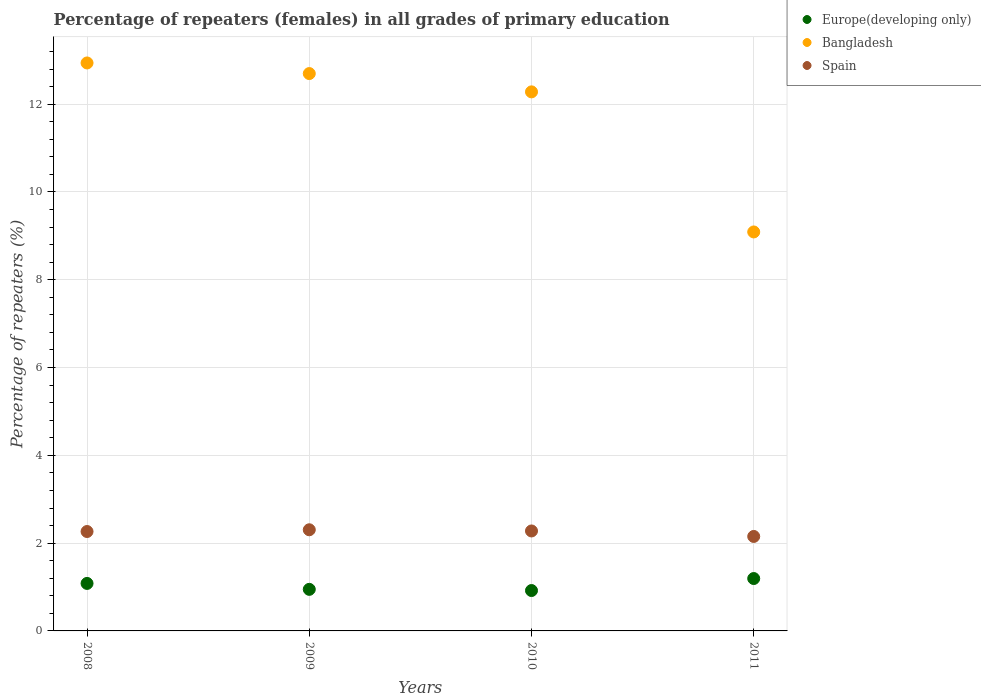What is the percentage of repeaters (females) in Spain in 2008?
Offer a terse response. 2.26. Across all years, what is the maximum percentage of repeaters (females) in Bangladesh?
Ensure brevity in your answer.  12.94. Across all years, what is the minimum percentage of repeaters (females) in Spain?
Your response must be concise. 2.15. In which year was the percentage of repeaters (females) in Bangladesh maximum?
Make the answer very short. 2008. In which year was the percentage of repeaters (females) in Europe(developing only) minimum?
Ensure brevity in your answer.  2010. What is the total percentage of repeaters (females) in Europe(developing only) in the graph?
Provide a succinct answer. 4.14. What is the difference between the percentage of repeaters (females) in Europe(developing only) in 2008 and that in 2011?
Offer a terse response. -0.11. What is the difference between the percentage of repeaters (females) in Bangladesh in 2010 and the percentage of repeaters (females) in Europe(developing only) in 2009?
Offer a terse response. 11.33. What is the average percentage of repeaters (females) in Bangladesh per year?
Offer a terse response. 11.75. In the year 2011, what is the difference between the percentage of repeaters (females) in Spain and percentage of repeaters (females) in Bangladesh?
Offer a very short reply. -6.94. What is the ratio of the percentage of repeaters (females) in Spain in 2008 to that in 2010?
Provide a succinct answer. 0.99. Is the percentage of repeaters (females) in Bangladesh in 2009 less than that in 2010?
Your response must be concise. No. Is the difference between the percentage of repeaters (females) in Spain in 2008 and 2009 greater than the difference between the percentage of repeaters (females) in Bangladesh in 2008 and 2009?
Ensure brevity in your answer.  No. What is the difference between the highest and the second highest percentage of repeaters (females) in Europe(developing only)?
Give a very brief answer. 0.11. What is the difference between the highest and the lowest percentage of repeaters (females) in Europe(developing only)?
Keep it short and to the point. 0.27. Is the percentage of repeaters (females) in Bangladesh strictly less than the percentage of repeaters (females) in Europe(developing only) over the years?
Offer a very short reply. No. How many years are there in the graph?
Provide a short and direct response. 4. Are the values on the major ticks of Y-axis written in scientific E-notation?
Give a very brief answer. No. Where does the legend appear in the graph?
Keep it short and to the point. Top right. How are the legend labels stacked?
Provide a succinct answer. Vertical. What is the title of the graph?
Ensure brevity in your answer.  Percentage of repeaters (females) in all grades of primary education. What is the label or title of the X-axis?
Provide a succinct answer. Years. What is the label or title of the Y-axis?
Offer a terse response. Percentage of repeaters (%). What is the Percentage of repeaters (%) in Europe(developing only) in 2008?
Your response must be concise. 1.08. What is the Percentage of repeaters (%) of Bangladesh in 2008?
Provide a succinct answer. 12.94. What is the Percentage of repeaters (%) in Spain in 2008?
Provide a short and direct response. 2.26. What is the Percentage of repeaters (%) of Europe(developing only) in 2009?
Your answer should be compact. 0.95. What is the Percentage of repeaters (%) in Bangladesh in 2009?
Your answer should be very brief. 12.7. What is the Percentage of repeaters (%) in Spain in 2009?
Provide a short and direct response. 2.3. What is the Percentage of repeaters (%) of Europe(developing only) in 2010?
Give a very brief answer. 0.92. What is the Percentage of repeaters (%) in Bangladesh in 2010?
Provide a short and direct response. 12.28. What is the Percentage of repeaters (%) in Spain in 2010?
Give a very brief answer. 2.28. What is the Percentage of repeaters (%) in Europe(developing only) in 2011?
Provide a short and direct response. 1.19. What is the Percentage of repeaters (%) in Bangladesh in 2011?
Offer a very short reply. 9.09. What is the Percentage of repeaters (%) of Spain in 2011?
Offer a terse response. 2.15. Across all years, what is the maximum Percentage of repeaters (%) in Europe(developing only)?
Make the answer very short. 1.19. Across all years, what is the maximum Percentage of repeaters (%) in Bangladesh?
Offer a terse response. 12.94. Across all years, what is the maximum Percentage of repeaters (%) of Spain?
Keep it short and to the point. 2.3. Across all years, what is the minimum Percentage of repeaters (%) in Europe(developing only)?
Give a very brief answer. 0.92. Across all years, what is the minimum Percentage of repeaters (%) of Bangladesh?
Make the answer very short. 9.09. Across all years, what is the minimum Percentage of repeaters (%) of Spain?
Ensure brevity in your answer.  2.15. What is the total Percentage of repeaters (%) in Europe(developing only) in the graph?
Your answer should be very brief. 4.14. What is the total Percentage of repeaters (%) in Bangladesh in the graph?
Offer a very short reply. 47. What is the total Percentage of repeaters (%) of Spain in the graph?
Your answer should be compact. 9. What is the difference between the Percentage of repeaters (%) in Europe(developing only) in 2008 and that in 2009?
Your response must be concise. 0.14. What is the difference between the Percentage of repeaters (%) of Bangladesh in 2008 and that in 2009?
Give a very brief answer. 0.24. What is the difference between the Percentage of repeaters (%) in Spain in 2008 and that in 2009?
Offer a very short reply. -0.04. What is the difference between the Percentage of repeaters (%) of Europe(developing only) in 2008 and that in 2010?
Give a very brief answer. 0.16. What is the difference between the Percentage of repeaters (%) in Bangladesh in 2008 and that in 2010?
Provide a short and direct response. 0.66. What is the difference between the Percentage of repeaters (%) in Spain in 2008 and that in 2010?
Provide a short and direct response. -0.01. What is the difference between the Percentage of repeaters (%) of Europe(developing only) in 2008 and that in 2011?
Offer a very short reply. -0.11. What is the difference between the Percentage of repeaters (%) in Bangladesh in 2008 and that in 2011?
Offer a terse response. 3.85. What is the difference between the Percentage of repeaters (%) of Spain in 2008 and that in 2011?
Your answer should be very brief. 0.11. What is the difference between the Percentage of repeaters (%) of Europe(developing only) in 2009 and that in 2010?
Your answer should be compact. 0.03. What is the difference between the Percentage of repeaters (%) in Bangladesh in 2009 and that in 2010?
Provide a succinct answer. 0.42. What is the difference between the Percentage of repeaters (%) of Spain in 2009 and that in 2010?
Provide a succinct answer. 0.03. What is the difference between the Percentage of repeaters (%) of Europe(developing only) in 2009 and that in 2011?
Offer a terse response. -0.25. What is the difference between the Percentage of repeaters (%) in Bangladesh in 2009 and that in 2011?
Keep it short and to the point. 3.61. What is the difference between the Percentage of repeaters (%) of Spain in 2009 and that in 2011?
Keep it short and to the point. 0.15. What is the difference between the Percentage of repeaters (%) of Europe(developing only) in 2010 and that in 2011?
Make the answer very short. -0.27. What is the difference between the Percentage of repeaters (%) of Bangladesh in 2010 and that in 2011?
Your response must be concise. 3.19. What is the difference between the Percentage of repeaters (%) in Spain in 2010 and that in 2011?
Keep it short and to the point. 0.13. What is the difference between the Percentage of repeaters (%) of Europe(developing only) in 2008 and the Percentage of repeaters (%) of Bangladesh in 2009?
Provide a short and direct response. -11.61. What is the difference between the Percentage of repeaters (%) of Europe(developing only) in 2008 and the Percentage of repeaters (%) of Spain in 2009?
Your answer should be very brief. -1.22. What is the difference between the Percentage of repeaters (%) of Bangladesh in 2008 and the Percentage of repeaters (%) of Spain in 2009?
Give a very brief answer. 10.63. What is the difference between the Percentage of repeaters (%) of Europe(developing only) in 2008 and the Percentage of repeaters (%) of Bangladesh in 2010?
Offer a terse response. -11.2. What is the difference between the Percentage of repeaters (%) of Europe(developing only) in 2008 and the Percentage of repeaters (%) of Spain in 2010?
Your response must be concise. -1.2. What is the difference between the Percentage of repeaters (%) of Bangladesh in 2008 and the Percentage of repeaters (%) of Spain in 2010?
Your answer should be compact. 10.66. What is the difference between the Percentage of repeaters (%) in Europe(developing only) in 2008 and the Percentage of repeaters (%) in Bangladesh in 2011?
Your answer should be compact. -8.01. What is the difference between the Percentage of repeaters (%) in Europe(developing only) in 2008 and the Percentage of repeaters (%) in Spain in 2011?
Your answer should be compact. -1.07. What is the difference between the Percentage of repeaters (%) in Bangladesh in 2008 and the Percentage of repeaters (%) in Spain in 2011?
Provide a short and direct response. 10.79. What is the difference between the Percentage of repeaters (%) of Europe(developing only) in 2009 and the Percentage of repeaters (%) of Bangladesh in 2010?
Offer a terse response. -11.33. What is the difference between the Percentage of repeaters (%) of Europe(developing only) in 2009 and the Percentage of repeaters (%) of Spain in 2010?
Make the answer very short. -1.33. What is the difference between the Percentage of repeaters (%) of Bangladesh in 2009 and the Percentage of repeaters (%) of Spain in 2010?
Provide a short and direct response. 10.42. What is the difference between the Percentage of repeaters (%) in Europe(developing only) in 2009 and the Percentage of repeaters (%) in Bangladesh in 2011?
Keep it short and to the point. -8.14. What is the difference between the Percentage of repeaters (%) of Europe(developing only) in 2009 and the Percentage of repeaters (%) of Spain in 2011?
Ensure brevity in your answer.  -1.21. What is the difference between the Percentage of repeaters (%) in Bangladesh in 2009 and the Percentage of repeaters (%) in Spain in 2011?
Your response must be concise. 10.54. What is the difference between the Percentage of repeaters (%) in Europe(developing only) in 2010 and the Percentage of repeaters (%) in Bangladesh in 2011?
Offer a terse response. -8.17. What is the difference between the Percentage of repeaters (%) of Europe(developing only) in 2010 and the Percentage of repeaters (%) of Spain in 2011?
Keep it short and to the point. -1.23. What is the difference between the Percentage of repeaters (%) of Bangladesh in 2010 and the Percentage of repeaters (%) of Spain in 2011?
Your response must be concise. 10.13. What is the average Percentage of repeaters (%) of Europe(developing only) per year?
Offer a terse response. 1.04. What is the average Percentage of repeaters (%) of Bangladesh per year?
Keep it short and to the point. 11.75. What is the average Percentage of repeaters (%) of Spain per year?
Offer a very short reply. 2.25. In the year 2008, what is the difference between the Percentage of repeaters (%) in Europe(developing only) and Percentage of repeaters (%) in Bangladesh?
Offer a very short reply. -11.86. In the year 2008, what is the difference between the Percentage of repeaters (%) in Europe(developing only) and Percentage of repeaters (%) in Spain?
Make the answer very short. -1.18. In the year 2008, what is the difference between the Percentage of repeaters (%) of Bangladesh and Percentage of repeaters (%) of Spain?
Make the answer very short. 10.67. In the year 2009, what is the difference between the Percentage of repeaters (%) of Europe(developing only) and Percentage of repeaters (%) of Bangladesh?
Your response must be concise. -11.75. In the year 2009, what is the difference between the Percentage of repeaters (%) in Europe(developing only) and Percentage of repeaters (%) in Spain?
Offer a very short reply. -1.36. In the year 2009, what is the difference between the Percentage of repeaters (%) of Bangladesh and Percentage of repeaters (%) of Spain?
Keep it short and to the point. 10.39. In the year 2010, what is the difference between the Percentage of repeaters (%) of Europe(developing only) and Percentage of repeaters (%) of Bangladesh?
Ensure brevity in your answer.  -11.36. In the year 2010, what is the difference between the Percentage of repeaters (%) in Europe(developing only) and Percentage of repeaters (%) in Spain?
Ensure brevity in your answer.  -1.36. In the year 2010, what is the difference between the Percentage of repeaters (%) in Bangladesh and Percentage of repeaters (%) in Spain?
Ensure brevity in your answer.  10. In the year 2011, what is the difference between the Percentage of repeaters (%) of Europe(developing only) and Percentage of repeaters (%) of Bangladesh?
Your answer should be very brief. -7.9. In the year 2011, what is the difference between the Percentage of repeaters (%) of Europe(developing only) and Percentage of repeaters (%) of Spain?
Offer a very short reply. -0.96. In the year 2011, what is the difference between the Percentage of repeaters (%) of Bangladesh and Percentage of repeaters (%) of Spain?
Offer a very short reply. 6.94. What is the ratio of the Percentage of repeaters (%) of Europe(developing only) in 2008 to that in 2009?
Offer a terse response. 1.14. What is the ratio of the Percentage of repeaters (%) in Bangladesh in 2008 to that in 2009?
Offer a terse response. 1.02. What is the ratio of the Percentage of repeaters (%) in Spain in 2008 to that in 2009?
Give a very brief answer. 0.98. What is the ratio of the Percentage of repeaters (%) of Europe(developing only) in 2008 to that in 2010?
Your response must be concise. 1.18. What is the ratio of the Percentage of repeaters (%) of Bangladesh in 2008 to that in 2010?
Provide a succinct answer. 1.05. What is the ratio of the Percentage of repeaters (%) in Spain in 2008 to that in 2010?
Ensure brevity in your answer.  0.99. What is the ratio of the Percentage of repeaters (%) of Europe(developing only) in 2008 to that in 2011?
Keep it short and to the point. 0.91. What is the ratio of the Percentage of repeaters (%) in Bangladesh in 2008 to that in 2011?
Your answer should be compact. 1.42. What is the ratio of the Percentage of repeaters (%) of Spain in 2008 to that in 2011?
Your answer should be compact. 1.05. What is the ratio of the Percentage of repeaters (%) in Europe(developing only) in 2009 to that in 2010?
Provide a short and direct response. 1.03. What is the ratio of the Percentage of repeaters (%) in Bangladesh in 2009 to that in 2010?
Provide a succinct answer. 1.03. What is the ratio of the Percentage of repeaters (%) in Spain in 2009 to that in 2010?
Keep it short and to the point. 1.01. What is the ratio of the Percentage of repeaters (%) in Europe(developing only) in 2009 to that in 2011?
Keep it short and to the point. 0.79. What is the ratio of the Percentage of repeaters (%) of Bangladesh in 2009 to that in 2011?
Make the answer very short. 1.4. What is the ratio of the Percentage of repeaters (%) of Spain in 2009 to that in 2011?
Provide a succinct answer. 1.07. What is the ratio of the Percentage of repeaters (%) in Europe(developing only) in 2010 to that in 2011?
Provide a succinct answer. 0.77. What is the ratio of the Percentage of repeaters (%) in Bangladesh in 2010 to that in 2011?
Ensure brevity in your answer.  1.35. What is the ratio of the Percentage of repeaters (%) of Spain in 2010 to that in 2011?
Offer a very short reply. 1.06. What is the difference between the highest and the second highest Percentage of repeaters (%) in Europe(developing only)?
Ensure brevity in your answer.  0.11. What is the difference between the highest and the second highest Percentage of repeaters (%) of Bangladesh?
Your response must be concise. 0.24. What is the difference between the highest and the second highest Percentage of repeaters (%) in Spain?
Your response must be concise. 0.03. What is the difference between the highest and the lowest Percentage of repeaters (%) of Europe(developing only)?
Offer a terse response. 0.27. What is the difference between the highest and the lowest Percentage of repeaters (%) of Bangladesh?
Your response must be concise. 3.85. What is the difference between the highest and the lowest Percentage of repeaters (%) in Spain?
Provide a succinct answer. 0.15. 